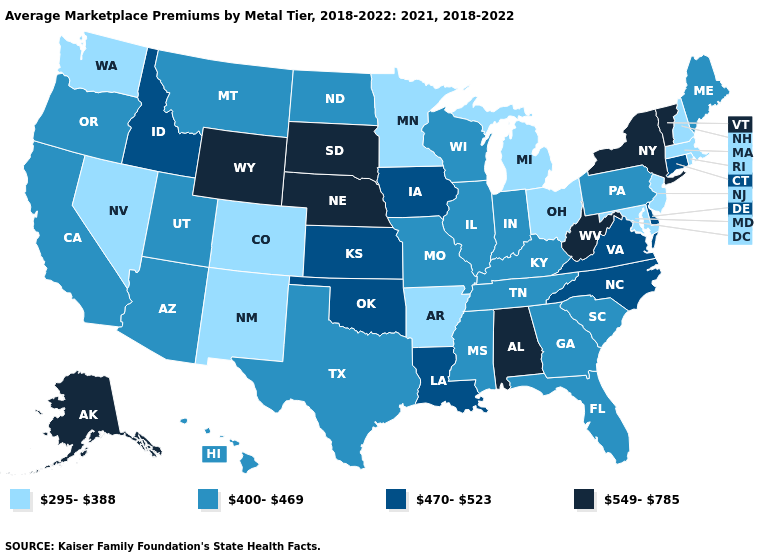Which states have the lowest value in the West?
Give a very brief answer. Colorado, Nevada, New Mexico, Washington. What is the lowest value in the West?
Give a very brief answer. 295-388. Name the states that have a value in the range 295-388?
Answer briefly. Arkansas, Colorado, Maryland, Massachusetts, Michigan, Minnesota, Nevada, New Hampshire, New Jersey, New Mexico, Ohio, Rhode Island, Washington. What is the value of Illinois?
Keep it brief. 400-469. How many symbols are there in the legend?
Keep it brief. 4. What is the value of Missouri?
Concise answer only. 400-469. Name the states that have a value in the range 295-388?
Concise answer only. Arkansas, Colorado, Maryland, Massachusetts, Michigan, Minnesota, Nevada, New Hampshire, New Jersey, New Mexico, Ohio, Rhode Island, Washington. What is the value of Arkansas?
Be succinct. 295-388. Which states have the lowest value in the USA?
Be succinct. Arkansas, Colorado, Maryland, Massachusetts, Michigan, Minnesota, Nevada, New Hampshire, New Jersey, New Mexico, Ohio, Rhode Island, Washington. What is the highest value in states that border New York?
Give a very brief answer. 549-785. Name the states that have a value in the range 295-388?
Give a very brief answer. Arkansas, Colorado, Maryland, Massachusetts, Michigan, Minnesota, Nevada, New Hampshire, New Jersey, New Mexico, Ohio, Rhode Island, Washington. What is the value of Delaware?
Short answer required. 470-523. Is the legend a continuous bar?
Keep it brief. No. What is the highest value in the USA?
Be succinct. 549-785. What is the value of New Hampshire?
Write a very short answer. 295-388. 